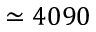Convert formula to latex. <formula><loc_0><loc_0><loc_500><loc_500>\simeq 4 0 9 0</formula> 